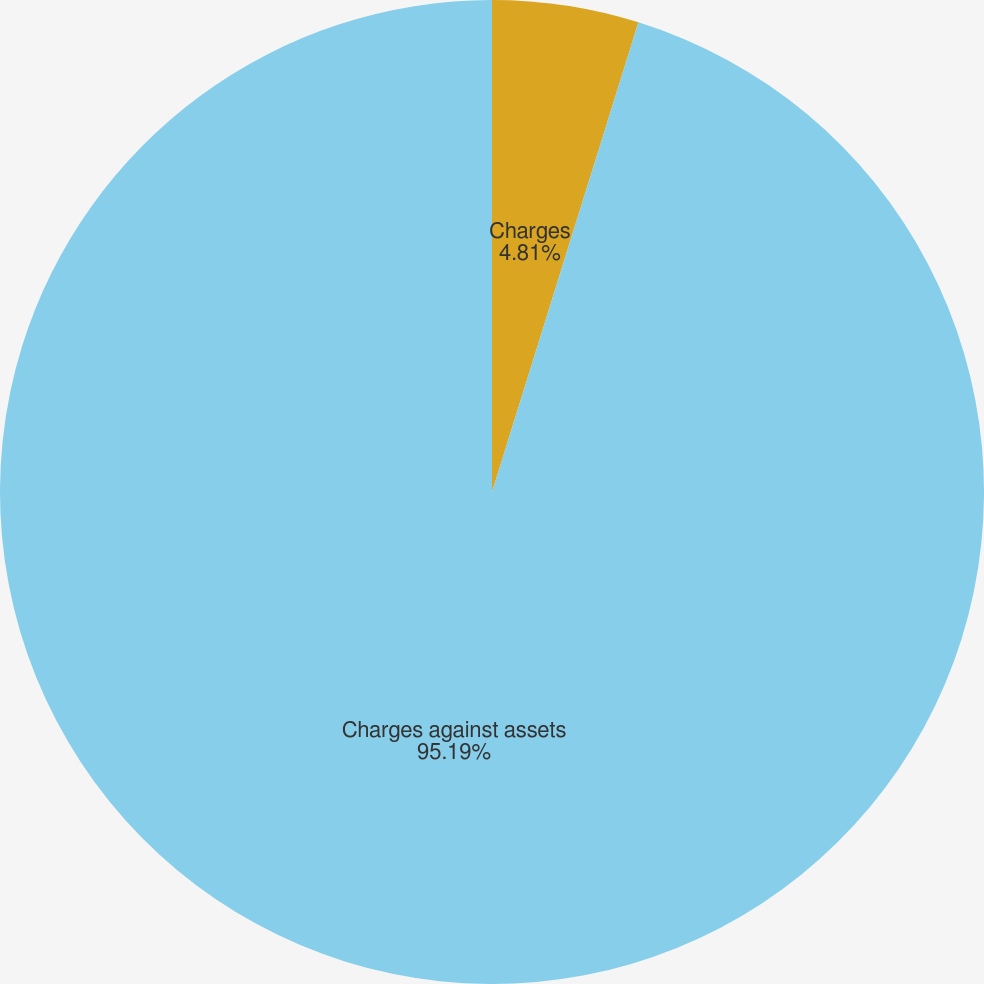Convert chart to OTSL. <chart><loc_0><loc_0><loc_500><loc_500><pie_chart><fcel>Charges<fcel>Charges against assets<nl><fcel>4.81%<fcel>95.19%<nl></chart> 